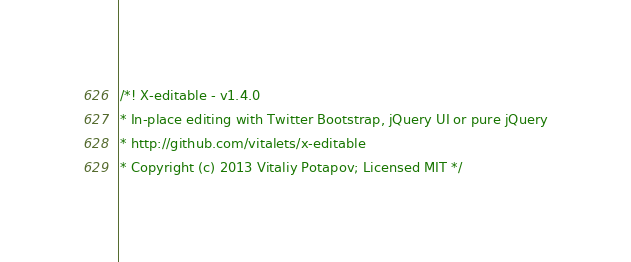<code> <loc_0><loc_0><loc_500><loc_500><_JavaScript_>/*! X-editable - v1.4.0 
* In-place editing with Twitter Bootstrap, jQuery UI or pure jQuery
* http://github.com/vitalets/x-editable
* Copyright (c) 2013 Vitaliy Potapov; Licensed MIT */</code> 